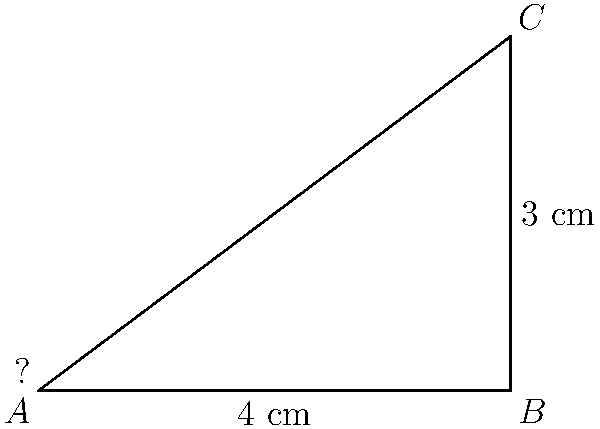As a filmmaker using a wide-angle lens, you need to calculate the angle of view. If the camera's sensor width is 4 cm and the focal length of the lens is 3 cm, what is the horizontal angle of view? Use the right-angled triangle method to determine this angle, which is crucial for framing your shots in Nigerian cinema. To calculate the angle of view using the right-angled triangle method:

1) The sensor width forms the base of the triangle (4 cm).
2) The focal length forms the height of the triangle (3 cm).
3) Half of the angle of view is formed at point A.

We can use the tangent function to find this angle:

$$\tan(\frac{\theta}{2}) = \frac{\text{opposite}}{\text{adjacent}} = \frac{2}{3}$$

Where 2 is half the sensor width (4/2 cm) and 3 is the focal length.

Now, we solve for $\theta$:

$$\frac{\theta}{2} = \arctan(\frac{2}{3})$$
$$\theta = 2 \cdot \arctan(\frac{2}{3})$$

Using a calculator:
$$\theta \approx 2 \cdot 33.69° = 67.38°$$

Round to the nearest degree: 67°

This is the full horizontal angle of view for the lens.
Answer: 67° 